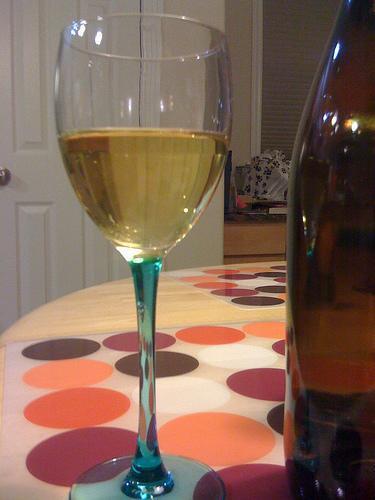How many bottles are there?
Give a very brief answer. 1. 